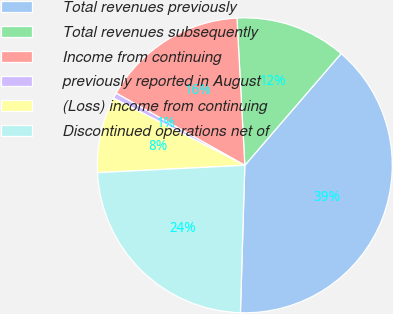Convert chart to OTSL. <chart><loc_0><loc_0><loc_500><loc_500><pie_chart><fcel>Total revenues previously<fcel>Total revenues subsequently<fcel>Income from continuing<fcel>previously reported in August<fcel>(Loss) income from continuing<fcel>Discontinued operations net of<nl><fcel>39.15%<fcel>12.17%<fcel>16.02%<fcel>0.61%<fcel>8.32%<fcel>23.73%<nl></chart> 